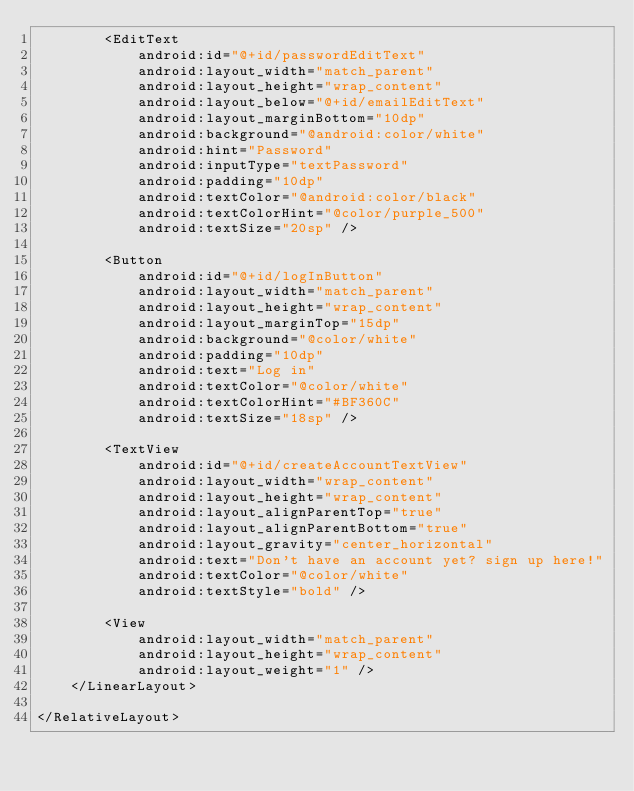Convert code to text. <code><loc_0><loc_0><loc_500><loc_500><_XML_>        <EditText
            android:id="@+id/passwordEditText"
            android:layout_width="match_parent"
            android:layout_height="wrap_content"
            android:layout_below="@+id/emailEditText"
            android:layout_marginBottom="10dp"
            android:background="@android:color/white"
            android:hint="Password"
            android:inputType="textPassword"
            android:padding="10dp"
            android:textColor="@android:color/black"
            android:textColorHint="@color/purple_500"
            android:textSize="20sp" />

        <Button
            android:id="@+id/logInButton"
            android:layout_width="match_parent"
            android:layout_height="wrap_content"
            android:layout_marginTop="15dp"
            android:background="@color/white"
            android:padding="10dp"
            android:text="Log in"
            android:textColor="@color/white"
            android:textColorHint="#BF360C"
            android:textSize="18sp" />

        <TextView
            android:id="@+id/createAccountTextView"
            android:layout_width="wrap_content"
            android:layout_height="wrap_content"
            android:layout_alignParentTop="true"
            android:layout_alignParentBottom="true"
            android:layout_gravity="center_horizontal"
            android:text="Don't have an account yet? sign up here!"
            android:textColor="@color/white"
            android:textStyle="bold" />

        <View
            android:layout_width="match_parent"
            android:layout_height="wrap_content"
            android:layout_weight="1" />
    </LinearLayout>

</RelativeLayout></code> 